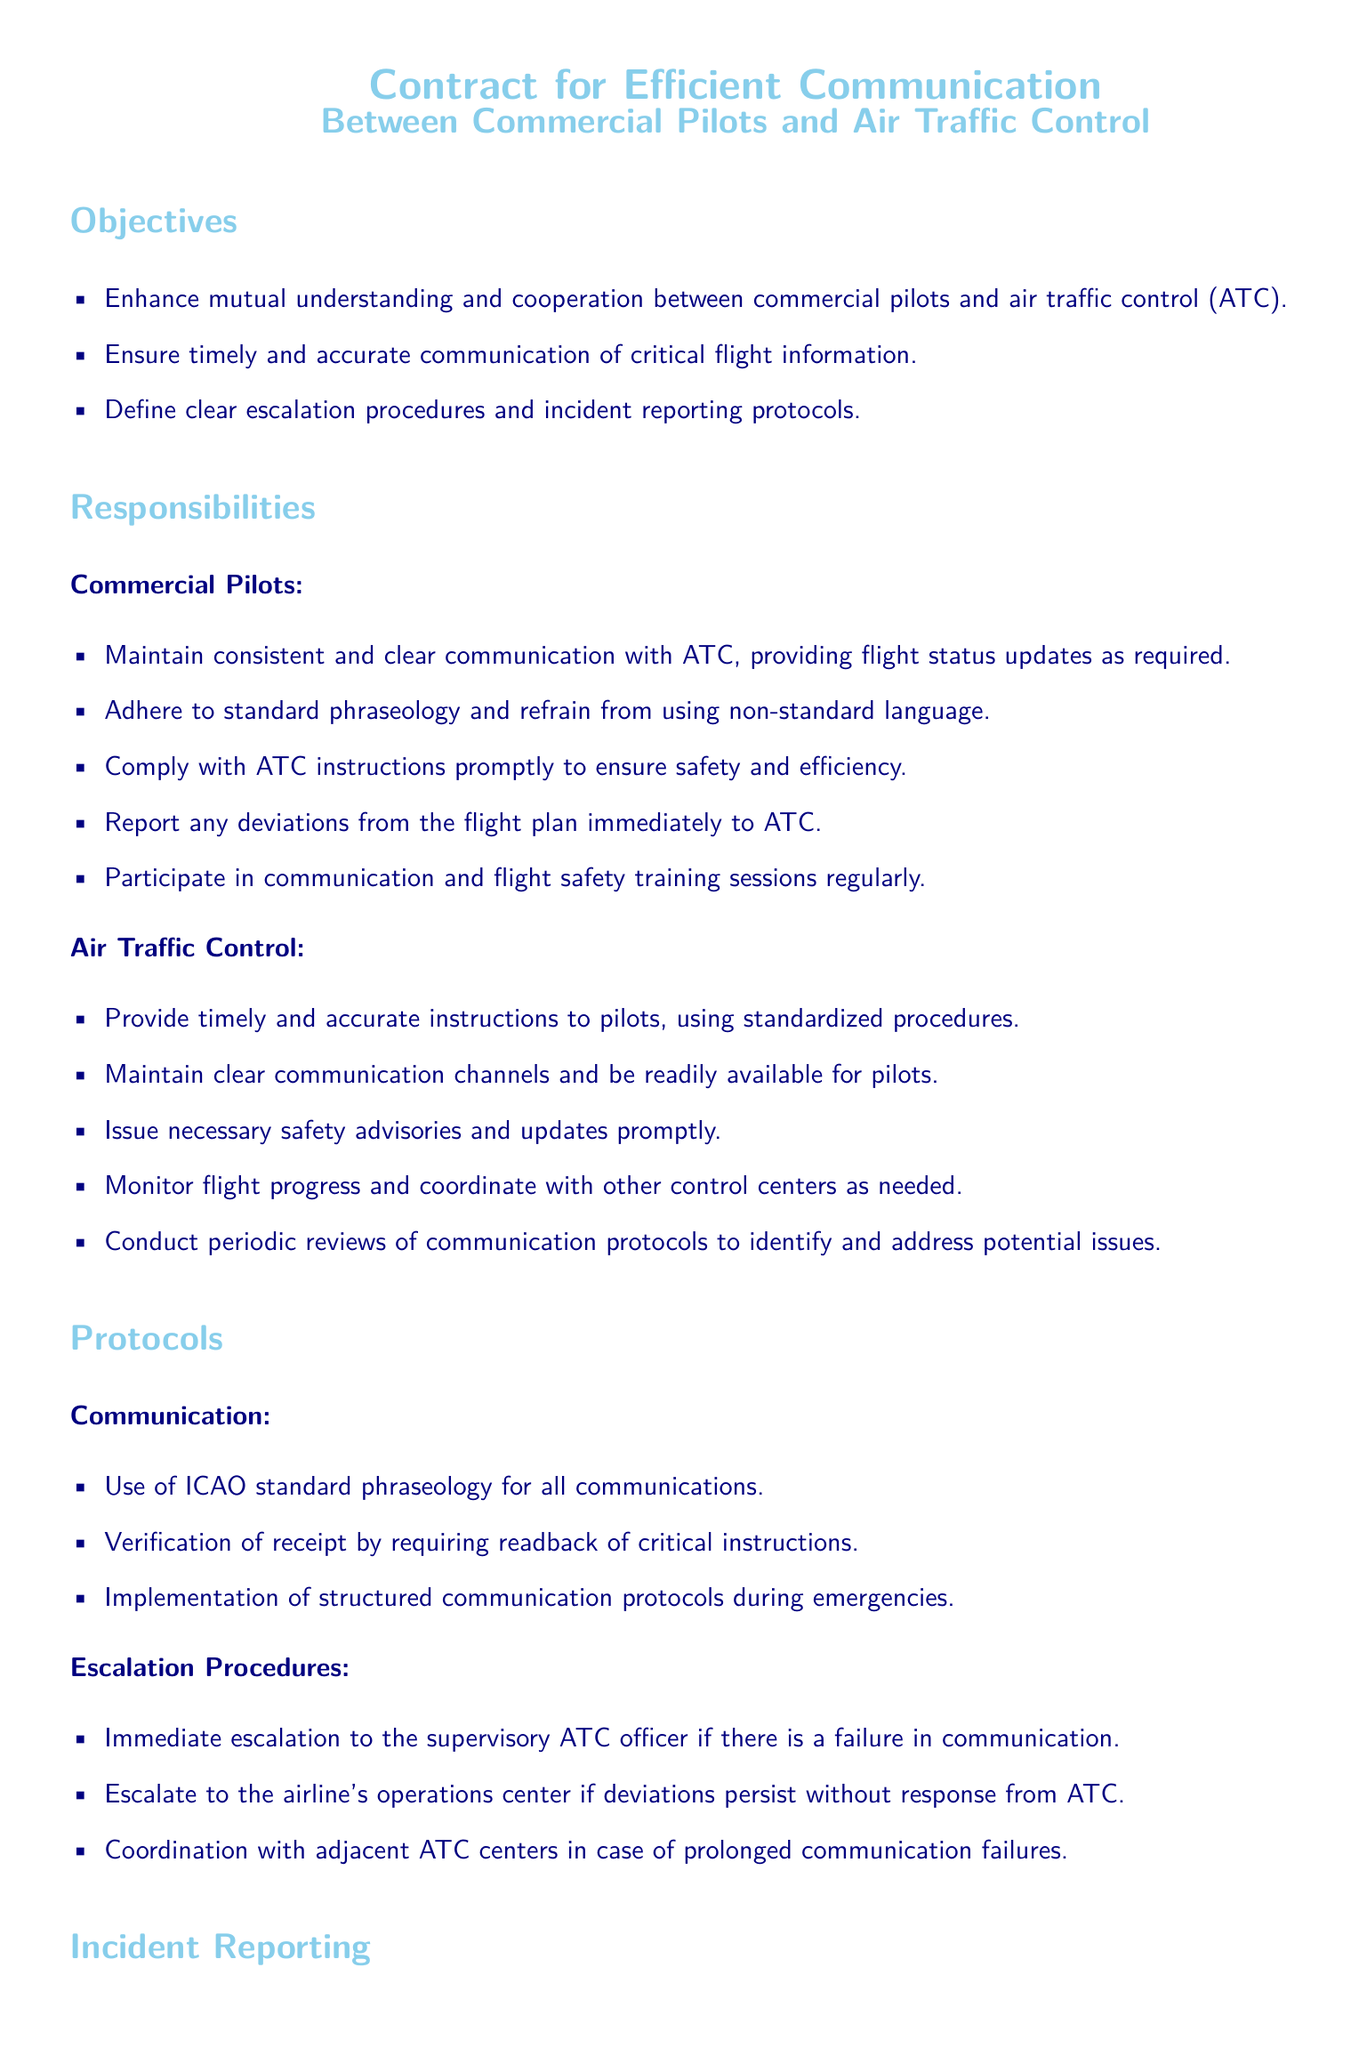What is the main objective of the contract? The contract aims to enhance mutual understanding and cooperation between commercial pilots and air traffic control, ensuring timely and accurate communication of critical flight information.
Answer: Enhance mutual understanding and cooperation What should pilots report immediately to ATC? The document specifies that pilots must report any deviations from the flight plan immediately to ATC.
Answer: Deviations from the flight plan What is required of pilots during emergencies? The document states that structured communication protocols should be implemented during emergencies.
Answer: Structured communication protocols What should a pilot do within 24 hours of an incident? According to the document, a pilot must submit the incident report to the airline's safety and operations department within 24 hours.
Answer: Submit the report Who logs the incident in the ATC incident reporting system? The ATC is responsible for logging the incident in the ATC incident reporting system.
Answer: ATC What is the key phraseology to be used in communication? The document instructs that ICAO standard phraseology must be used for all communications.
Answer: ICAO standard phraseology What is the escalation procedure for communication failures? If there's a failure in communication, immediate escalation to the supervisory ATC officer is required.
Answer: Immediate escalation to the supervisory ATC officer Who is responsible for documenting incident details? The pilot is responsible for documenting the incident details, including time, nature of the issue, and steps taken.
Answer: Pilot 